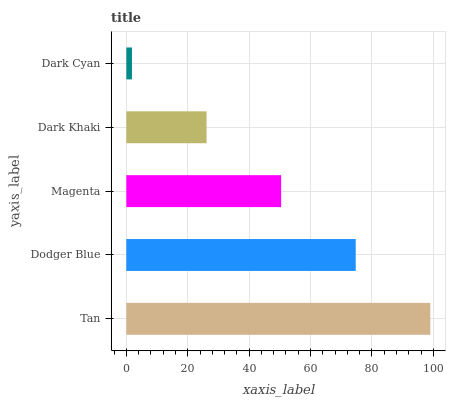Is Dark Cyan the minimum?
Answer yes or no. Yes. Is Tan the maximum?
Answer yes or no. Yes. Is Dodger Blue the minimum?
Answer yes or no. No. Is Dodger Blue the maximum?
Answer yes or no. No. Is Tan greater than Dodger Blue?
Answer yes or no. Yes. Is Dodger Blue less than Tan?
Answer yes or no. Yes. Is Dodger Blue greater than Tan?
Answer yes or no. No. Is Tan less than Dodger Blue?
Answer yes or no. No. Is Magenta the high median?
Answer yes or no. Yes. Is Magenta the low median?
Answer yes or no. Yes. Is Tan the high median?
Answer yes or no. No. Is Dodger Blue the low median?
Answer yes or no. No. 